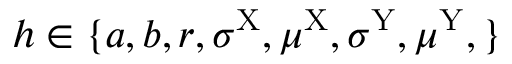Convert formula to latex. <formula><loc_0><loc_0><loc_500><loc_500>h \in \{ a , b , r , \sigma ^ { X } , \mu ^ { X } , \sigma ^ { Y } , \mu ^ { Y } , \}</formula> 